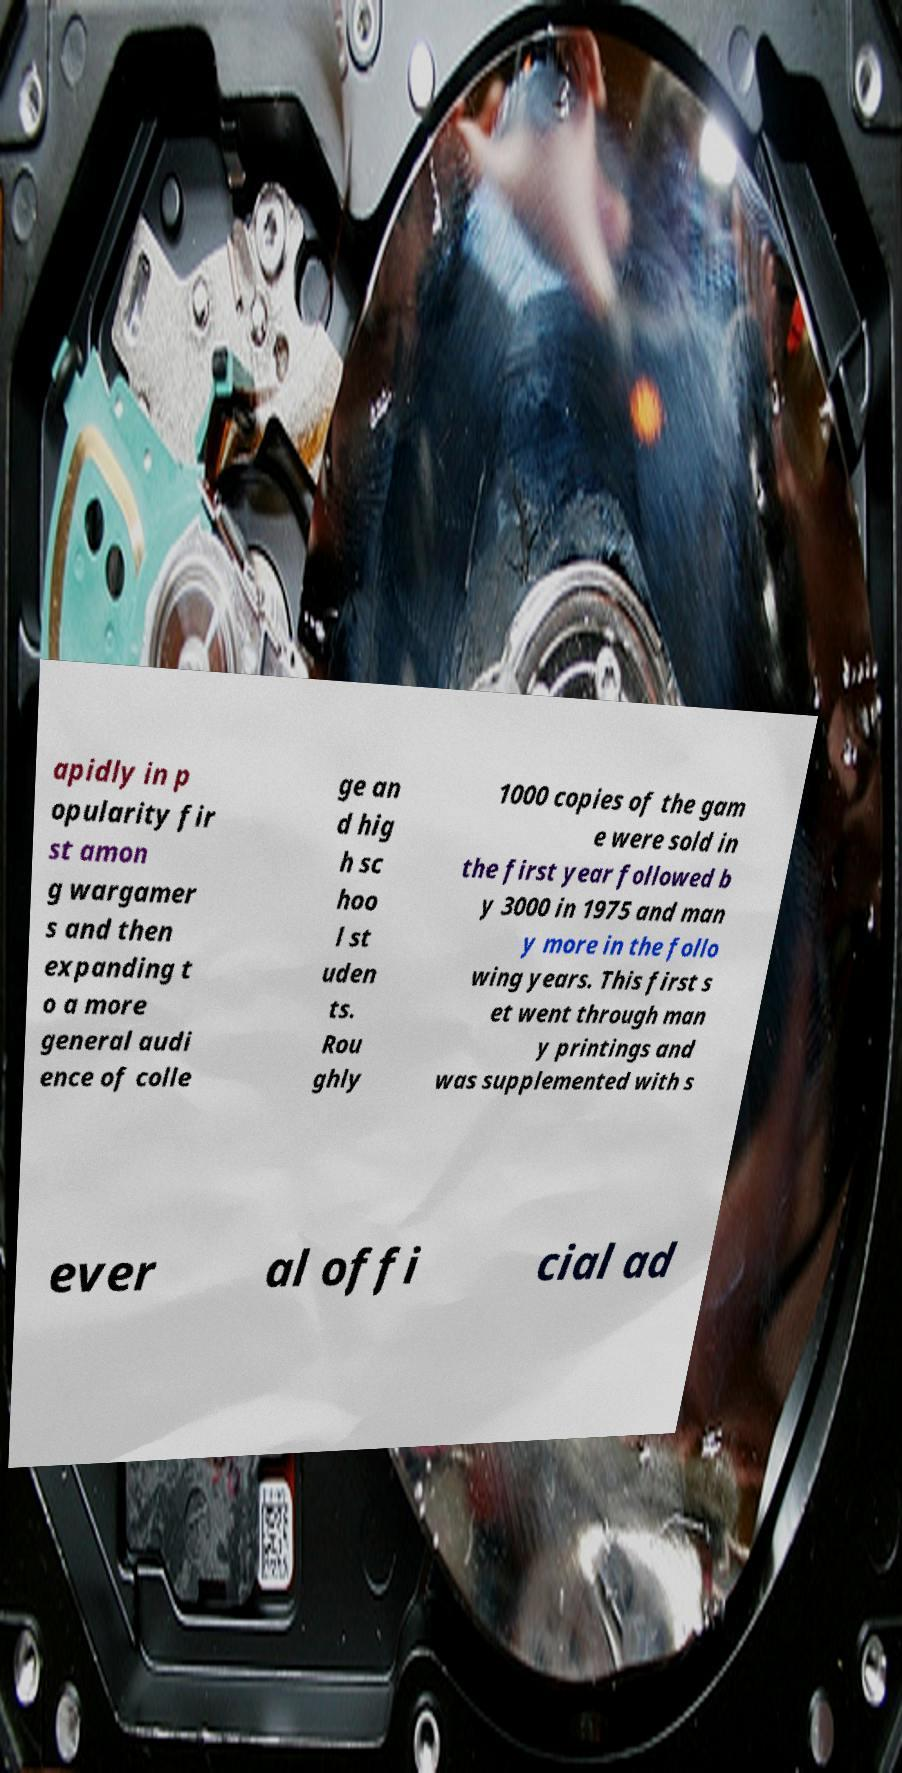What messages or text are displayed in this image? I need them in a readable, typed format. apidly in p opularity fir st amon g wargamer s and then expanding t o a more general audi ence of colle ge an d hig h sc hoo l st uden ts. Rou ghly 1000 copies of the gam e were sold in the first year followed b y 3000 in 1975 and man y more in the follo wing years. This first s et went through man y printings and was supplemented with s ever al offi cial ad 